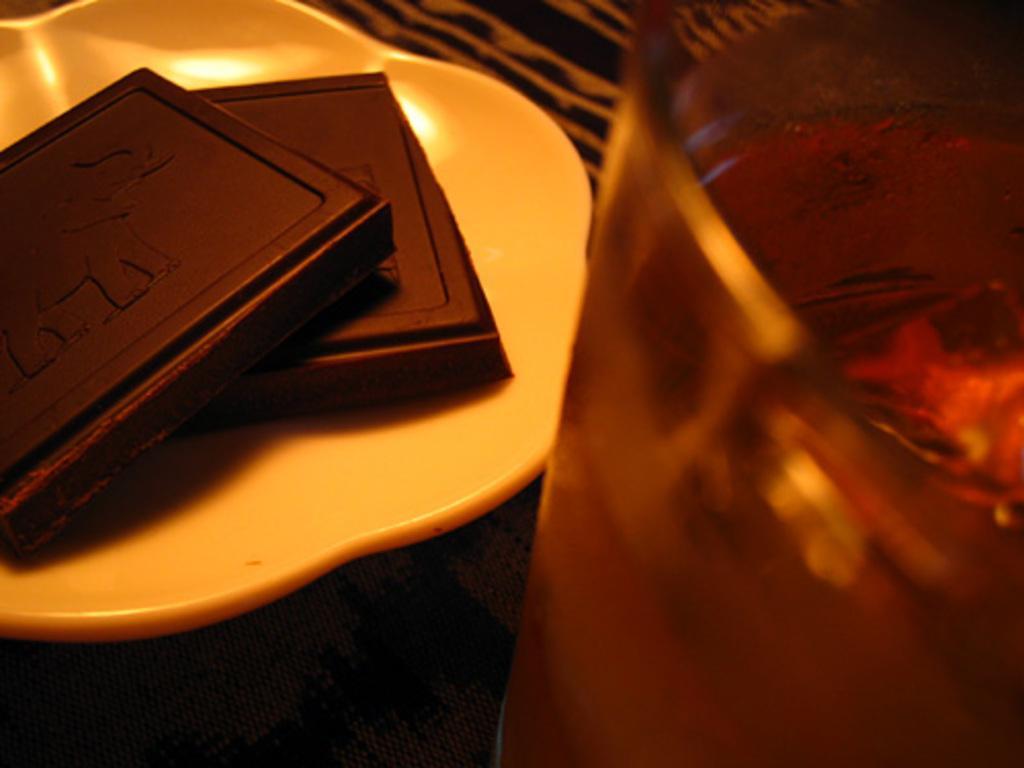Can you describe this image briefly? In this image we can see food items on the plate, there is an object on the right side of the image. 